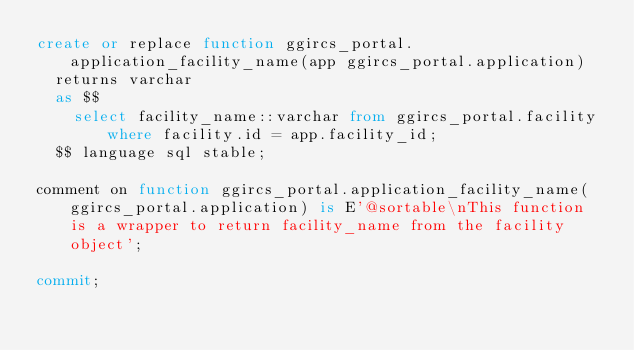Convert code to text. <code><loc_0><loc_0><loc_500><loc_500><_SQL_>create or replace function ggircs_portal.application_facility_name(app ggircs_portal.application)
  returns varchar
  as $$
    select facility_name::varchar from ggircs_portal.facility where facility.id = app.facility_id;
  $$ language sql stable;

comment on function ggircs_portal.application_facility_name(ggircs_portal.application) is E'@sortable\nThis function is a wrapper to return facility_name from the facility object';

commit;
</code> 